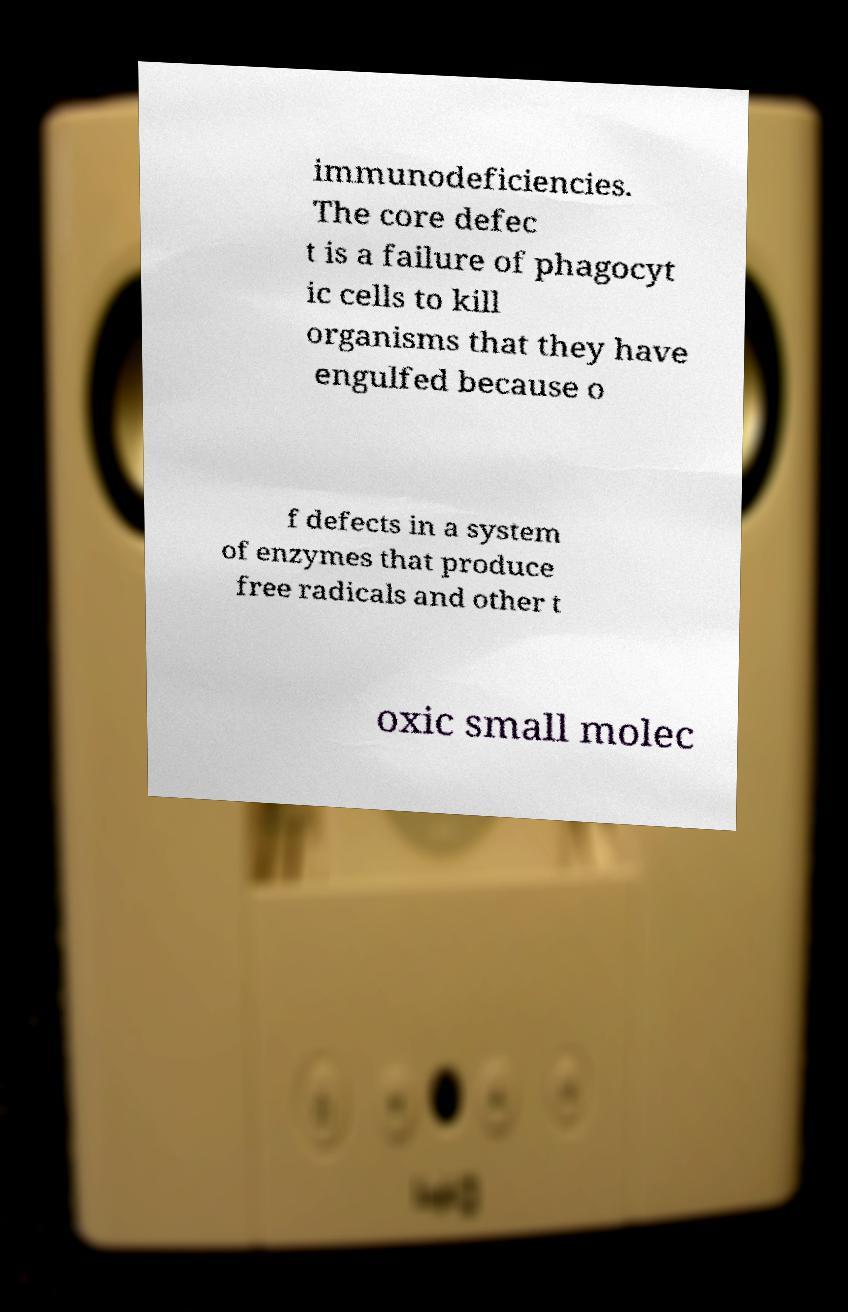What messages or text are displayed in this image? I need them in a readable, typed format. immunodeficiencies. The core defec t is a failure of phagocyt ic cells to kill organisms that they have engulfed because o f defects in a system of enzymes that produce free radicals and other t oxic small molec 